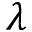Convert formula to latex. <formula><loc_0><loc_0><loc_500><loc_500>\lambda</formula> 